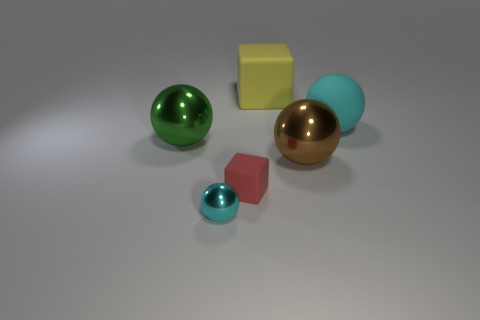How many big things have the same color as the small block?
Ensure brevity in your answer.  0. Is there anything else that has the same material as the large cyan thing?
Keep it short and to the point. Yes. Are there fewer large rubber blocks in front of the yellow matte thing than big objects?
Provide a succinct answer. Yes. What color is the thing that is to the left of the cyan sphere in front of the large cyan matte sphere?
Give a very brief answer. Green. What is the size of the metallic object to the right of the cyan object in front of the cube that is in front of the green thing?
Your answer should be very brief. Large. Are there fewer cyan metallic spheres left of the tiny shiny sphere than large green metal things that are behind the green thing?
Offer a very short reply. No. How many large blocks are the same material as the brown thing?
Offer a very short reply. 0. There is a red thing that is in front of the big metal object that is on the left side of the large yellow matte thing; is there a big ball on the right side of it?
Your response must be concise. Yes. There is a big yellow object that is the same material as the big cyan sphere; what shape is it?
Your answer should be compact. Cube. Is the number of yellow balls greater than the number of big spheres?
Your response must be concise. No. 